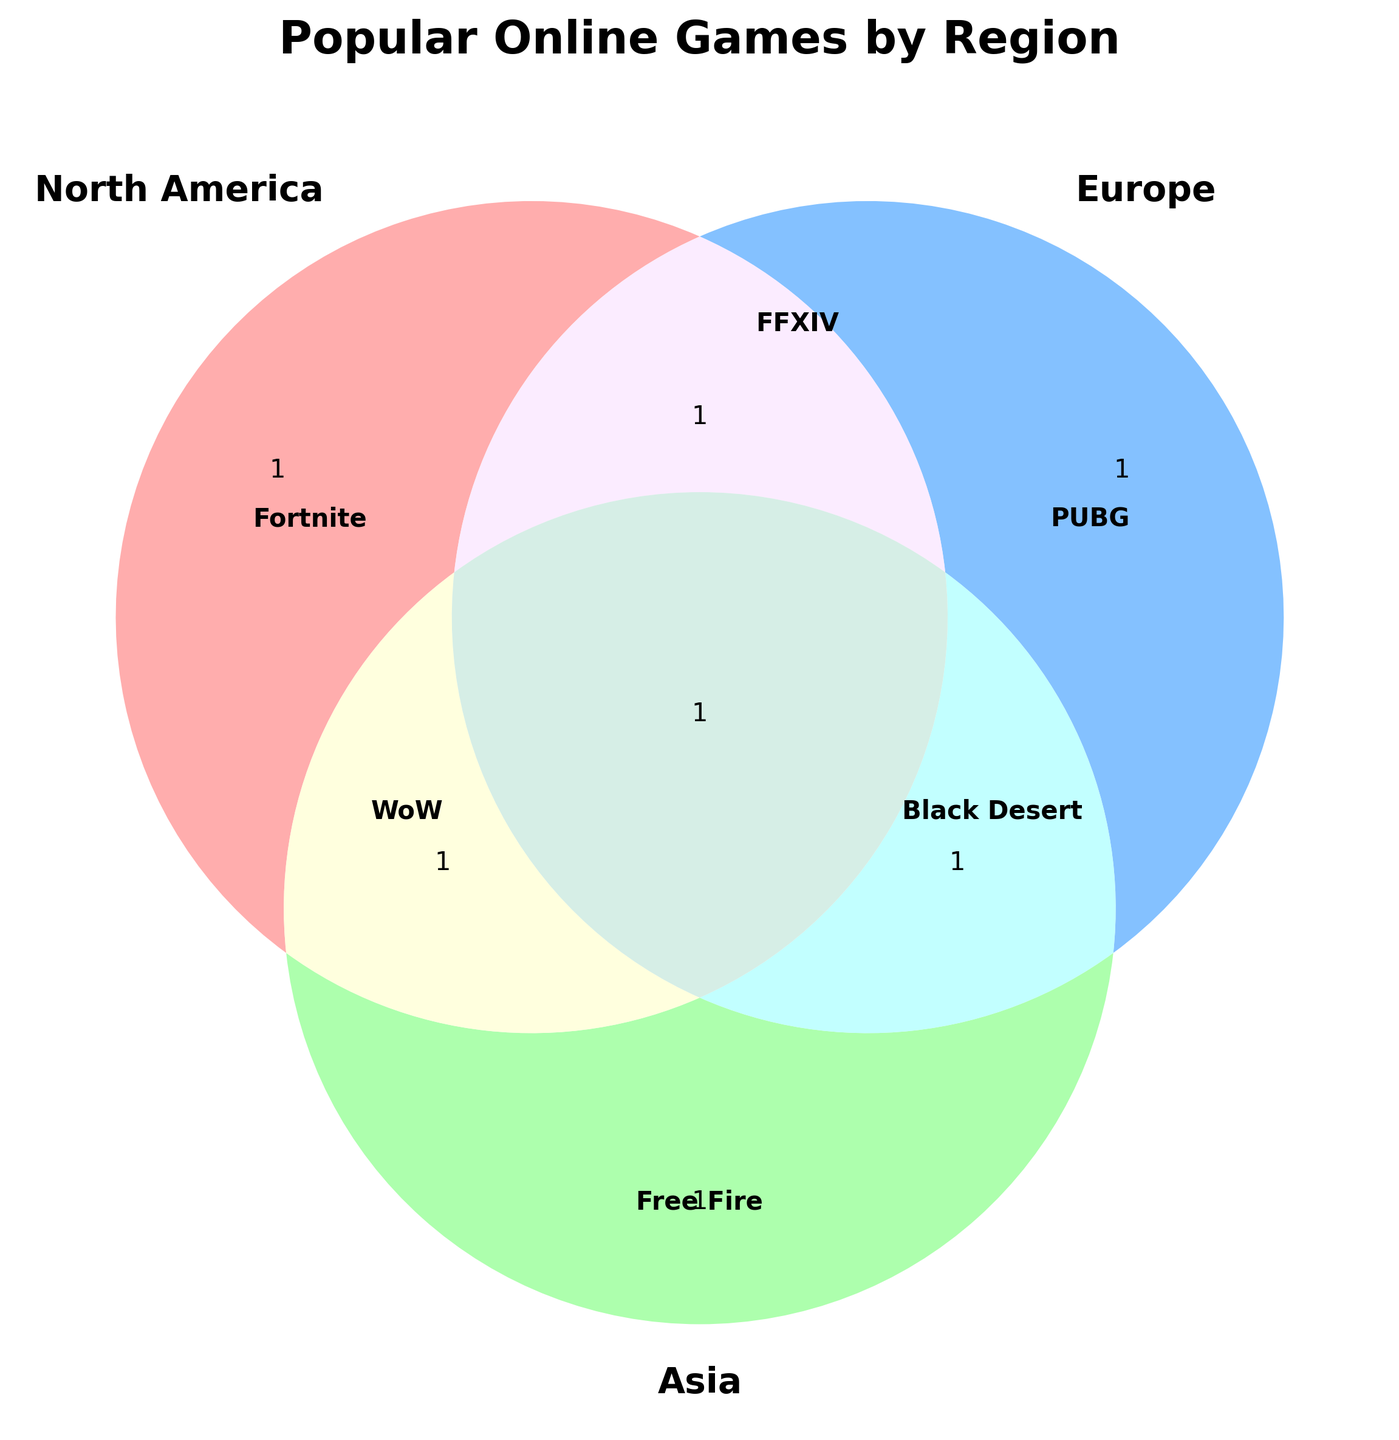What regions are represented in the Venn diagram? The Venn diagram has three labeled regions: North America, Europe, and Asia.
Answer: North America, Europe, Asia What is the main title of the Venn diagram? The title is prominently displayed above the Venn diagram.
Answer: Popular Online Games by Region Which game is popular in North America and is represented in the Venn diagram? The text label inside the North America section shows the name of the game.
Answer: Fortnite How many sets overlap in the Venn diagram? Venn diagram displays overlapping relationships between three sets.
Answer: Three sets What game titles are indicated inside the Asia section? The text label inside the Asia section shows the names of the games.
Answer: Free Fire, Black Desert What games are shared between Europe and Asia according to the diagram? Shared titles are located in the overlapping section between Europe and Asia.
Answer: Black Desert Online Which region has the highest number of unique game titles displayed? By counting the unique game titles for each region from the Venn diagram.
Answer: Asia (Free Fire, Black Desert, Honor of Kings, Genshin Impact, AfreecaTV) Is there any game that is common to all three regions in the Venn diagram? Check the central overlapping section of the Venn diagram to see if any game is listed.
Answer: No Which regions include the game World of Warcraft? The Venn diagram shows World of Warcraft in the section labeled for North America.
Answer: North America Compare the number of game titles in the Europe and North America sections. Which region has more? Count the game titles in the Europe and North America sections of the Venn diagram.
Answer: North America has more 